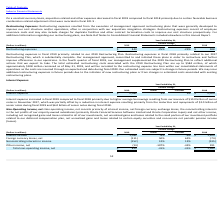Looking at Oracle Corporation's financial data, please calculate: How much was the average interest income in 2018 and 2019? To answer this question, I need to perform calculations using the financial data. The calculation is: (1,092+1,203) / 2 , which equals 1147.5 (in millions). This is based on the information: "Interest income $ 1,092 -9% -9% $ 1,203 Interest income $ 1,092 -9% -9% $ 1,203..." The key data points involved are: 1,092, 1,203. Also, can you calculate: What was the difference in other income, net in 2019 and 2018? Based on the calculation: 191 -(-14) , the result is 205 (in millions). This is based on the information: "Other income, net (14) -107% -42% 191 Other income, net (14) -107% -42% 191..." The key data points involved are: 14, 191. Also, can you calculate: How much was the total amount of foreign currency losses, net and interest income across 2018 and 2019? Based on the calculation: 1,092 + 1,203 - 111 - 74 , the result is 2110 (in millions). This is based on the information: "Foreign currency losses, net (111) 50% 62% (74) Interest income $ 1,092 -9% -9% $ 1,203 Interest income $ 1,092 -9% -9% $ 1,203 Foreign currency losses, net (111) 50% 62% (74)..." The key data points involved are: 1,092, 1,203, 111. Also, What is included in non-operating income? Non-operating income, net consists primarily of interest income, net foreign currency exchange losses, the noncontrolling interests in the net profits of our majority-owned subsidiaries (primarily Oracle Financial Services Software Limited and Oracle Corporation Japan) and net other income, including net recognized gains and losses related to all of our investments, net unrealized gains and losses related to the small portion of our investment portfolio related to our deferred compensation plan, net unrealized gains and losses related to certain equity securities and non-service net periodic pension income (losses).. The document states: "Non-Operating Income, net: Non-operating income, net consists primarily of interest income, net foreign currency exchange losses, the noncontrolling i..." Also, What are two of Oracle's majority-owned subsidiaries? Oracle Financial Services Software Limited and Oracle Corporation Japan. The document states: "its of our majority-owned subsidiaries (primarily Oracle Financial Services Software Limited and Oracle Corporation Japan) and net other income, inclu..." Also, Why did Oracle's interest income in fiscal 2019 decrease? Based on the financial document, the answer is lower interest income in fiscal 2019 primarily due to lower average cash, cash equivalent and marketable securities balances during fiscal 2019 .. 